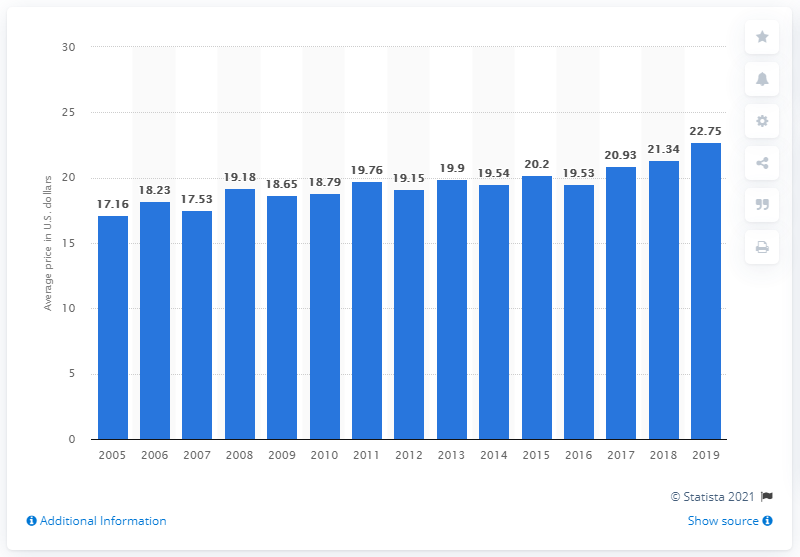Highlight a few significant elements in this photo. In 2019, the average price for a basic manicure in the United States was $22.75. In 2019, the average price for a basic manicure in the United States was $22.75. 